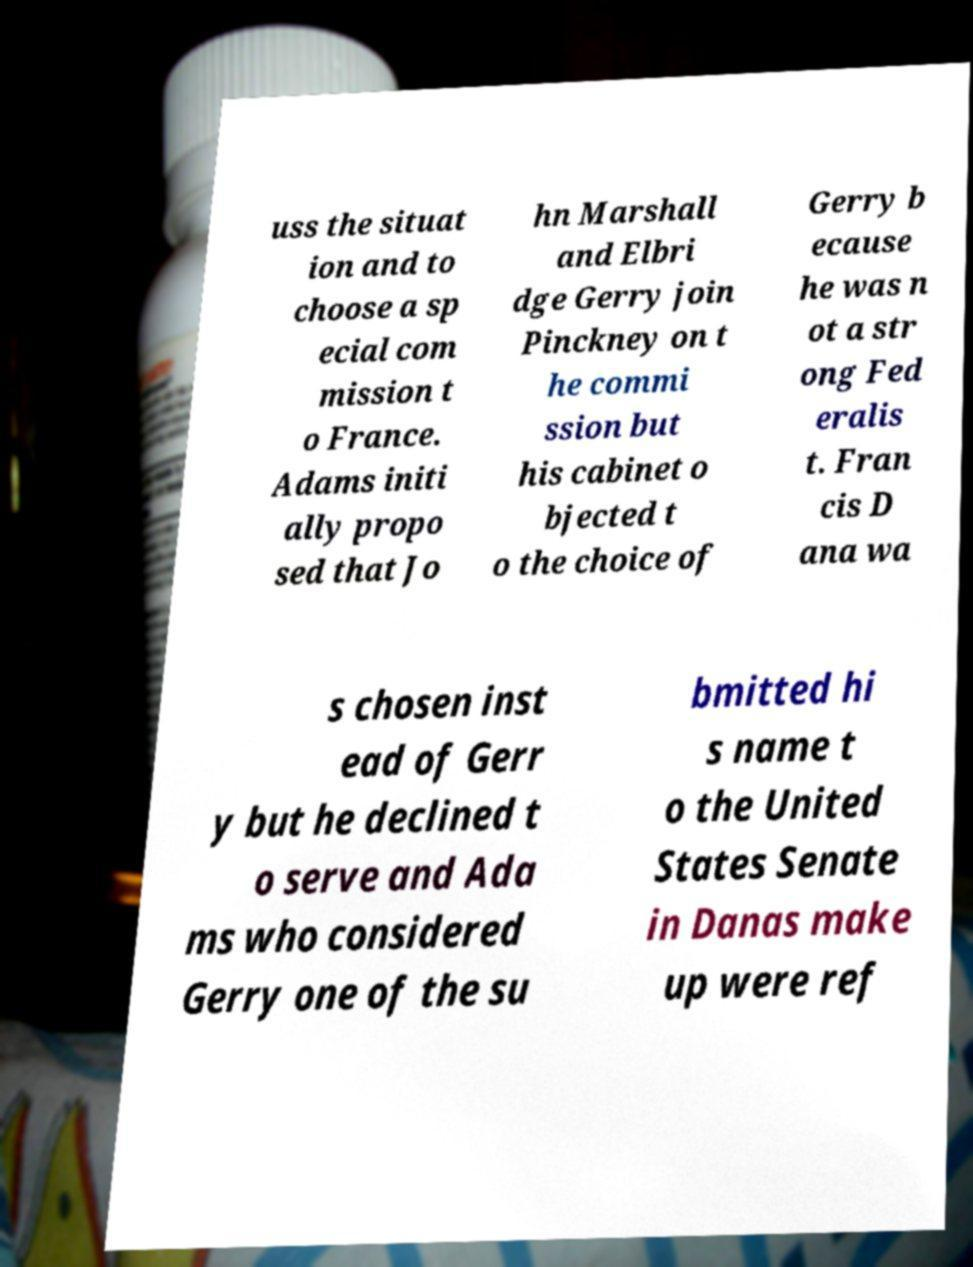Could you assist in decoding the text presented in this image and type it out clearly? uss the situat ion and to choose a sp ecial com mission t o France. Adams initi ally propo sed that Jo hn Marshall and Elbri dge Gerry join Pinckney on t he commi ssion but his cabinet o bjected t o the choice of Gerry b ecause he was n ot a str ong Fed eralis t. Fran cis D ana wa s chosen inst ead of Gerr y but he declined t o serve and Ada ms who considered Gerry one of the su bmitted hi s name t o the United States Senate in Danas make up were ref 